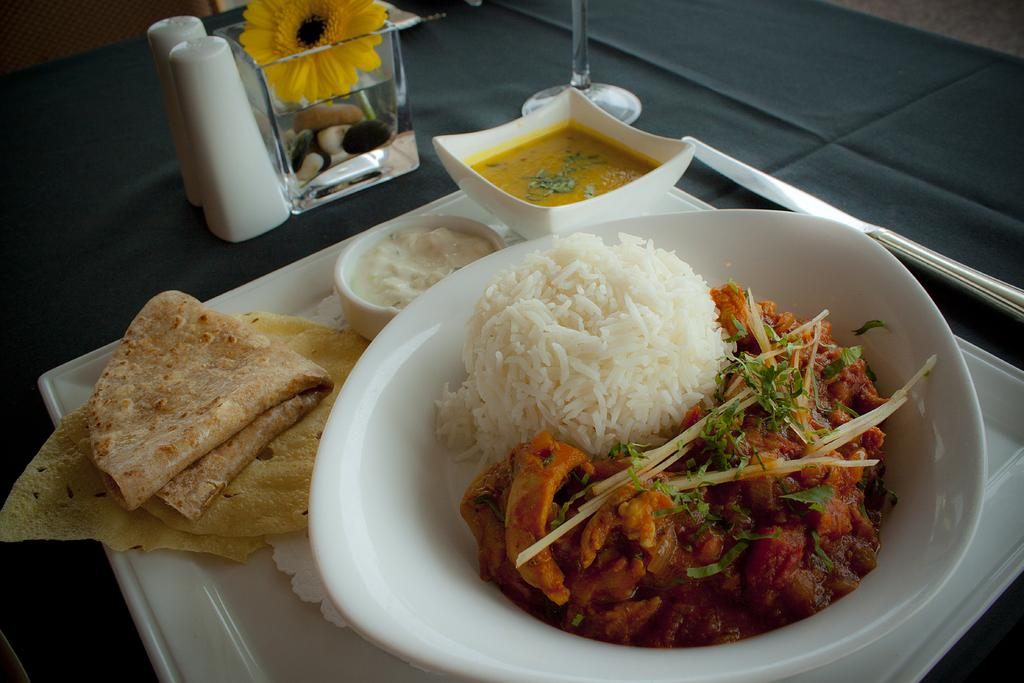What is in the bowl that is visible in the image? There is food in a bowl in the image. How is the bowl positioned in the image? The bowl is placed in a tray. What other objects can be seen in the image? There is a flower vase and a tumbler in the image. What type of support can be seen in the image? There is no specific support mentioned or visible in the image. 